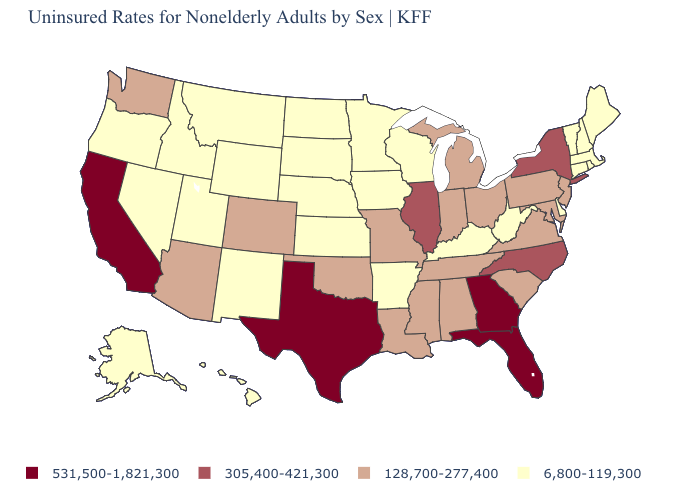Does New Mexico have the highest value in the USA?
Be succinct. No. Name the states that have a value in the range 128,700-277,400?
Quick response, please. Alabama, Arizona, Colorado, Indiana, Louisiana, Maryland, Michigan, Mississippi, Missouri, New Jersey, Ohio, Oklahoma, Pennsylvania, South Carolina, Tennessee, Virginia, Washington. What is the value of New York?
Quick response, please. 305,400-421,300. Does the first symbol in the legend represent the smallest category?
Be succinct. No. Name the states that have a value in the range 305,400-421,300?
Give a very brief answer. Illinois, New York, North Carolina. What is the highest value in the USA?
Be succinct. 531,500-1,821,300. Name the states that have a value in the range 128,700-277,400?
Be succinct. Alabama, Arizona, Colorado, Indiana, Louisiana, Maryland, Michigan, Mississippi, Missouri, New Jersey, Ohio, Oklahoma, Pennsylvania, South Carolina, Tennessee, Virginia, Washington. Name the states that have a value in the range 305,400-421,300?
Answer briefly. Illinois, New York, North Carolina. Which states have the lowest value in the West?
Be succinct. Alaska, Hawaii, Idaho, Montana, Nevada, New Mexico, Oregon, Utah, Wyoming. Does Vermont have a higher value than Wyoming?
Be succinct. No. Does Arizona have the highest value in the USA?
Be succinct. No. Which states have the lowest value in the USA?
Write a very short answer. Alaska, Arkansas, Connecticut, Delaware, Hawaii, Idaho, Iowa, Kansas, Kentucky, Maine, Massachusetts, Minnesota, Montana, Nebraska, Nevada, New Hampshire, New Mexico, North Dakota, Oregon, Rhode Island, South Dakota, Utah, Vermont, West Virginia, Wisconsin, Wyoming. Name the states that have a value in the range 305,400-421,300?
Quick response, please. Illinois, New York, North Carolina. Does Alaska have the highest value in the West?
Keep it brief. No. What is the highest value in the USA?
Short answer required. 531,500-1,821,300. 